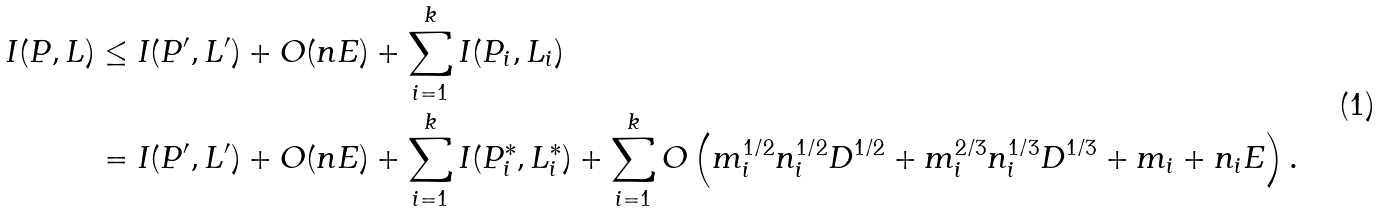<formula> <loc_0><loc_0><loc_500><loc_500>I ( P , L ) & \leq I ( P ^ { \prime } , L ^ { \prime } ) + O ( n E ) + \sum _ { i = 1 } ^ { k } I ( P _ { i } , L _ { i } ) \\ & = I ( P ^ { \prime } , L ^ { \prime } ) + O ( n E ) + \sum _ { i = 1 } ^ { k } I ( P _ { i } ^ { * } , L _ { i } ^ { * } ) + \sum _ { i = 1 } ^ { k } O \left ( m _ { i } ^ { 1 / 2 } n _ { i } ^ { 1 / 2 } D ^ { 1 / 2 } + m _ { i } ^ { 2 / 3 } n _ { i } ^ { 1 / 3 } D ^ { 1 / 3 } + m _ { i } + n _ { i } E \right ) .</formula> 